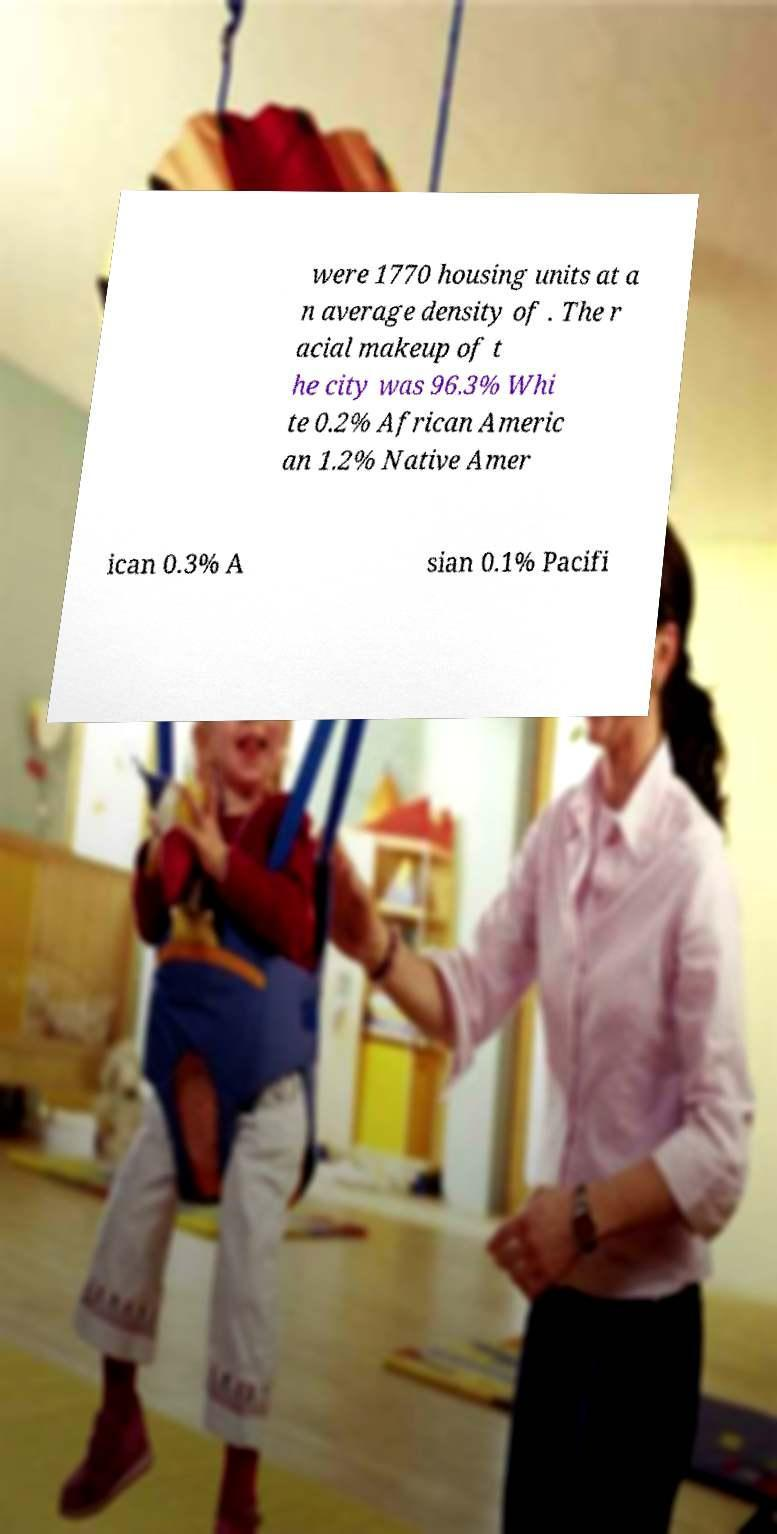Please identify and transcribe the text found in this image. were 1770 housing units at a n average density of . The r acial makeup of t he city was 96.3% Whi te 0.2% African Americ an 1.2% Native Amer ican 0.3% A sian 0.1% Pacifi 